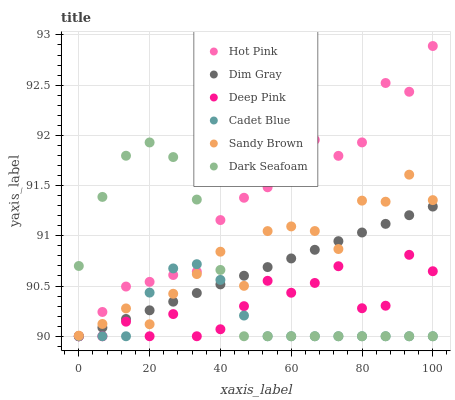Does Cadet Blue have the minimum area under the curve?
Answer yes or no. Yes. Does Hot Pink have the maximum area under the curve?
Answer yes or no. Yes. Does Deep Pink have the minimum area under the curve?
Answer yes or no. No. Does Deep Pink have the maximum area under the curve?
Answer yes or no. No. Is Dim Gray the smoothest?
Answer yes or no. Yes. Is Sandy Brown the roughest?
Answer yes or no. Yes. Is Hot Pink the smoothest?
Answer yes or no. No. Is Hot Pink the roughest?
Answer yes or no. No. Does Cadet Blue have the lowest value?
Answer yes or no. Yes. Does Sandy Brown have the lowest value?
Answer yes or no. No. Does Hot Pink have the highest value?
Answer yes or no. Yes. Does Deep Pink have the highest value?
Answer yes or no. No. Is Deep Pink less than Sandy Brown?
Answer yes or no. Yes. Is Sandy Brown greater than Deep Pink?
Answer yes or no. Yes. Does Dark Seafoam intersect Dim Gray?
Answer yes or no. Yes. Is Dark Seafoam less than Dim Gray?
Answer yes or no. No. Is Dark Seafoam greater than Dim Gray?
Answer yes or no. No. Does Deep Pink intersect Sandy Brown?
Answer yes or no. No. 